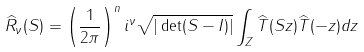<formula> <loc_0><loc_0><loc_500><loc_500>\widehat { R } _ { \nu } ( S ) = \left ( \frac { 1 } { 2 \pi } \right ) ^ { n } i ^ { \nu } \sqrt { | \det ( S - I ) | } \int _ { Z } \widehat { T } ( S z ) \widehat { T } ( - z ) d z</formula> 